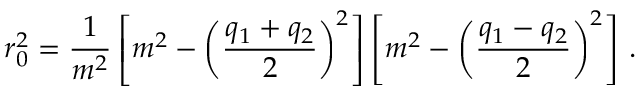<formula> <loc_0><loc_0><loc_500><loc_500>r _ { 0 } ^ { 2 } = \frac { 1 } { m ^ { 2 } } \left [ m ^ { 2 } - \left ( \frac { q _ { 1 } + q _ { 2 } } { 2 } \right ) ^ { 2 } \right ] \left [ m ^ { 2 } - \left ( \frac { q _ { 1 } - q _ { 2 } } { 2 } \right ) ^ { 2 } \right ] \, .</formula> 